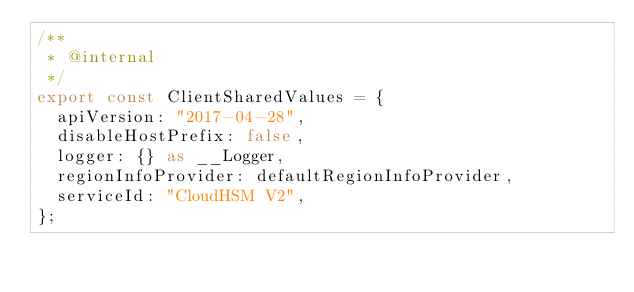Convert code to text. <code><loc_0><loc_0><loc_500><loc_500><_TypeScript_>/**
 * @internal
 */
export const ClientSharedValues = {
  apiVersion: "2017-04-28",
  disableHostPrefix: false,
  logger: {} as __Logger,
  regionInfoProvider: defaultRegionInfoProvider,
  serviceId: "CloudHSM V2",
};
</code> 